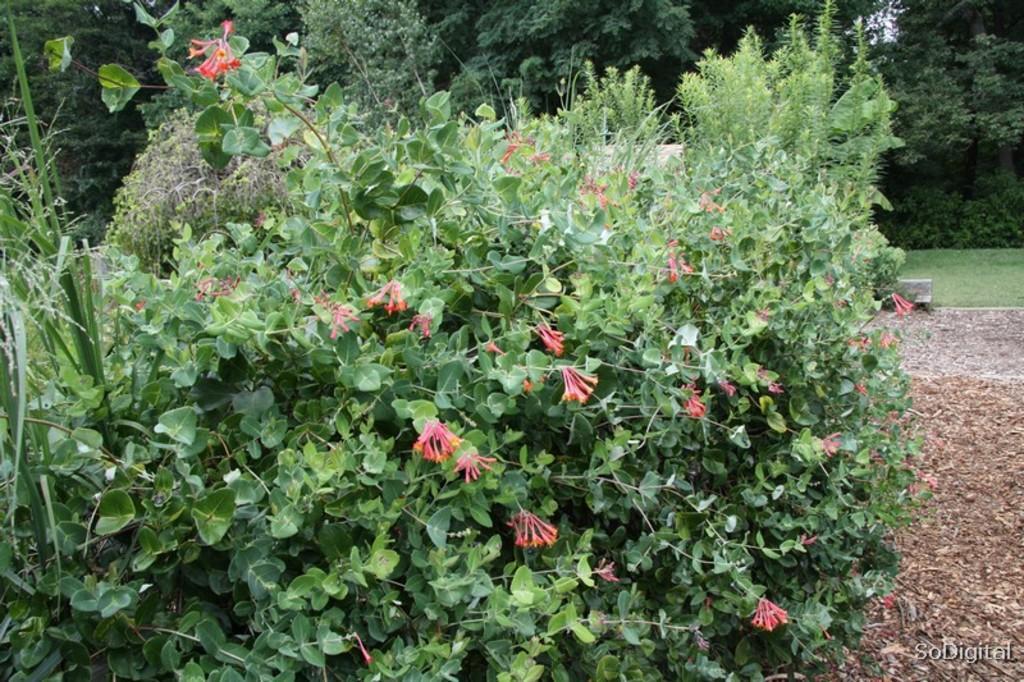How would you summarize this image in a sentence or two? In this image I can see number of trees and here I can see a ground. 